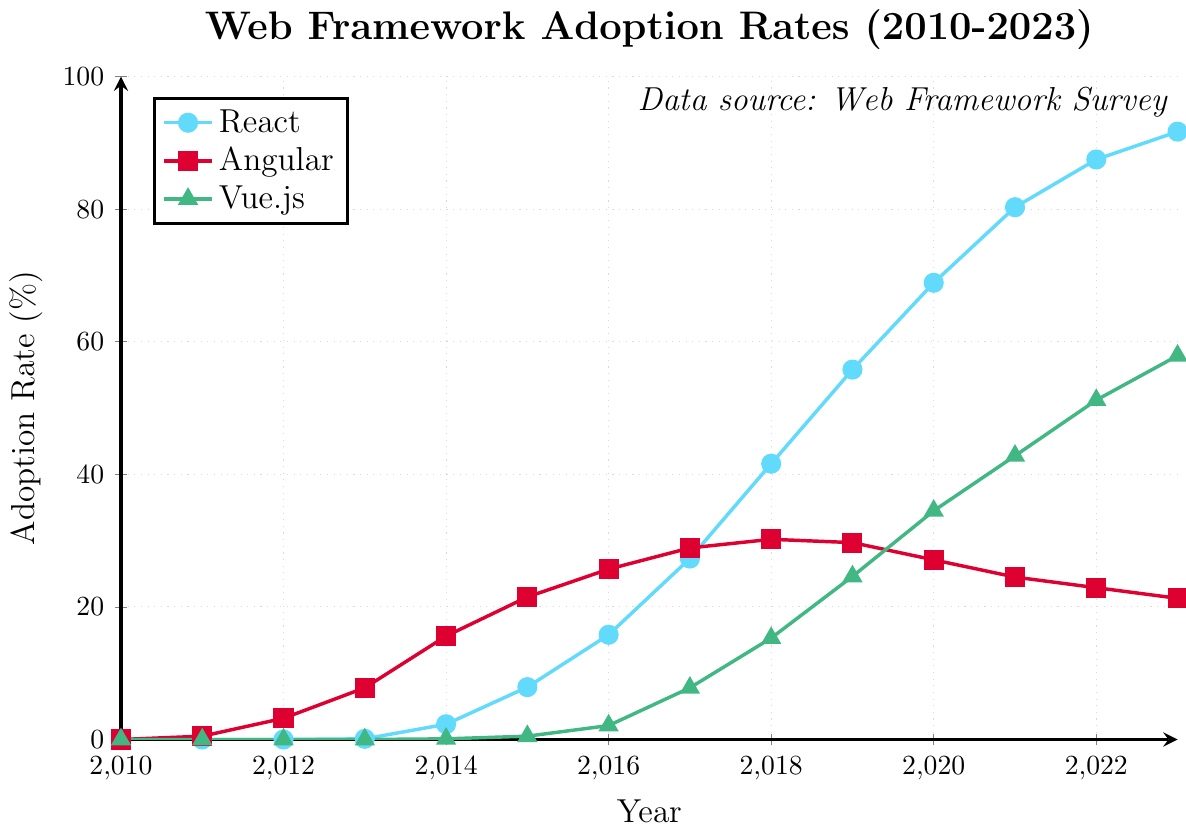What is the adoption rate of React in 2017? Looking at the figure, you can find the point representing React's adoption rate in 2017.
Answer: 27.3% Which framework had the highest adoption rate in 2023? By examining the end points for all three frameworks in 2023, React's adoption rate is the highest at 91.7%.
Answer: React Between 2010 and 2015, by how much did Angular's adoption rate increase? Angular's adoption rate in 2010 is 0% and in 2015 is 21.5%. The increase is 21.5% - 0% = 21.5%.
Answer: 21.5% How did Vue.js' adoption rate change from 2016 to 2020? In 2016, Vue.js had an adoption rate of 2.1%, which increased to 34.5% in 2020. The change is 34.5% - 2.1% = 32.4%.
Answer: 32.4% What is the combined adoption rate of React, Angular, and Vue.js in 2018? Adding the rates for 2018: React (41.6%) + Angular (30.2%) + Vue.js (15.3%) = 41.6 + 30.2 + 15.3 = 87.1%
Answer: 87.1% Which framework had a declining adoption rate after 2017? Observing the trends, Angular's adoption rate declined after 2017, dropping from 28.9% to 21.3% by 2023.
Answer: Angular What is the average annual increase in React's adoption rate between 2014 and 2019? To find the average annual increase: (55.8% - 2.3%) / (2019 - 2014) = 53.5% / 5 ≈ 10.7% per year.
Answer: 10.7% per year Compare the adoption rates of Angular and Vue.js in 2013. Which one was higher and by how much? In 2013, Angular had a rate of 7.8% and Vue.js had 0%. The difference is 7.8% - 0% = 7.8%. Angular was higher by 7.8%.
Answer: Angular, 7.8% Which framework shows the most consistent increase in adoption from 2010 to 2023? React shows a consistent and significant increase every year, as opposed to Angular and Vue.js, which have periods of stagnation or decline.
Answer: React 